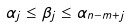Convert formula to latex. <formula><loc_0><loc_0><loc_500><loc_500>\alpha _ { j } \leq \beta _ { j } \leq \alpha _ { n - m + j }</formula> 